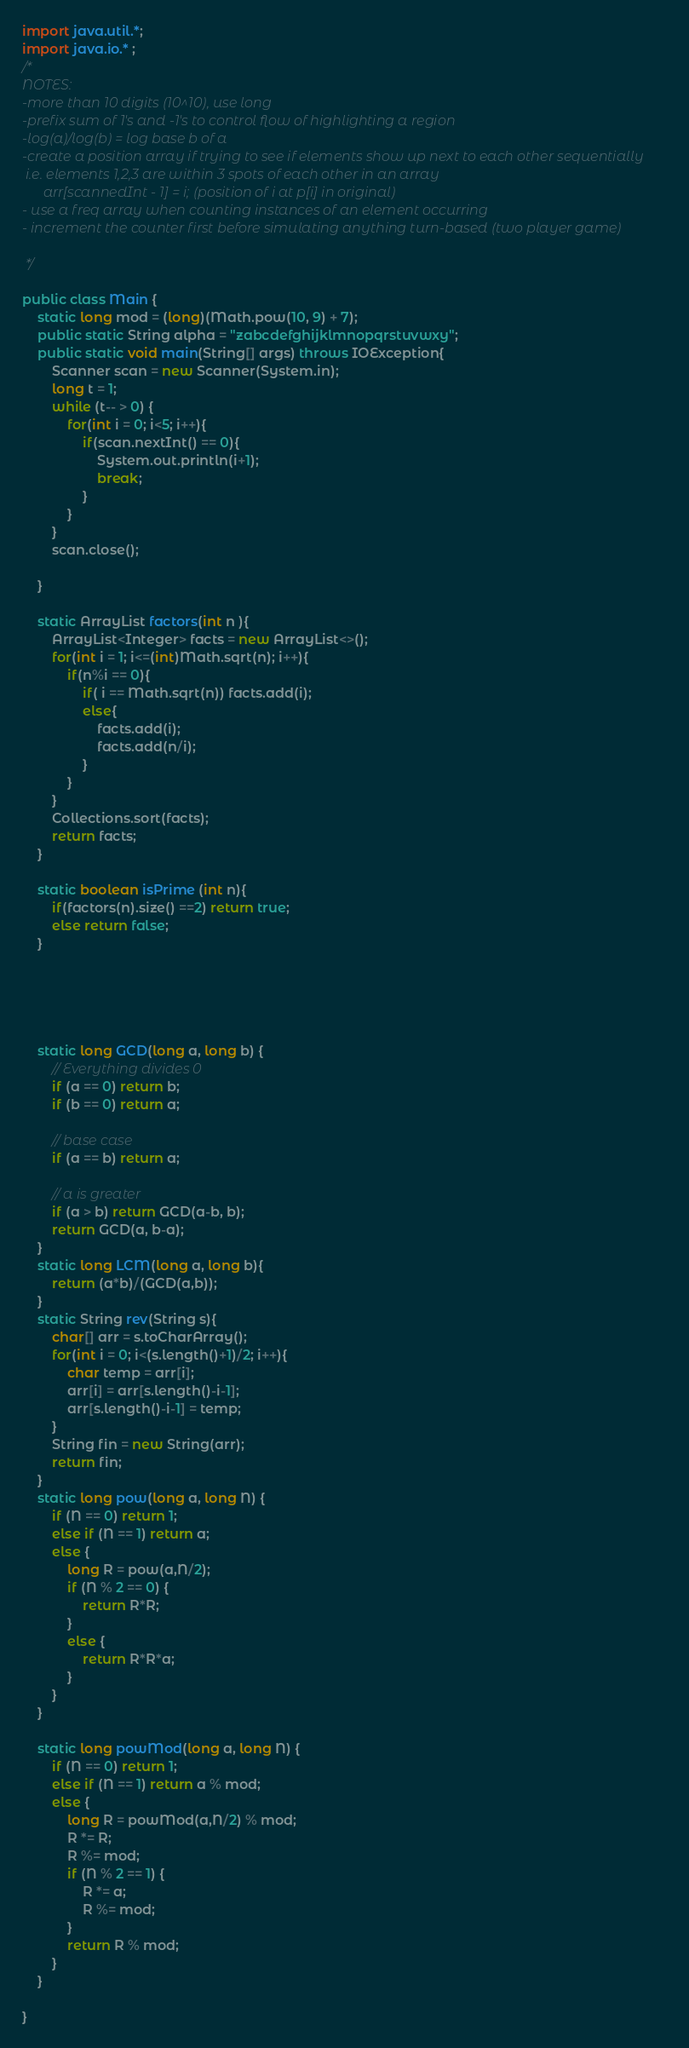Convert code to text. <code><loc_0><loc_0><loc_500><loc_500><_Java_>import java.util.*;
import java.io.* ;
/*
NOTES:
-more than 10 digits (10^10), use long
-prefix sum of 1's and -1's to control flow of highlighting a region
-log(a)/log(b) = log base b of a
-create a position array if trying to see if elements show up next to each other sequentially
 i.e. elements 1,2,3 are within 3 spots of each other in an array
      arr[scannedInt - 1] = i; (position of i at p[i] in original)
- use a freq array when counting instances of an element occurring
- increment the counter first before simulating anything turn-based (two player game)

 */

public class Main {
    static long mod = (long)(Math.pow(10, 9) + 7);
    public static String alpha = "zabcdefghijklmnopqrstuvwxy";
    public static void main(String[] args) throws IOException{
        Scanner scan = new Scanner(System.in);
        long t = 1;
        while (t-- > 0) {
            for(int i = 0; i<5; i++){
                if(scan.nextInt() == 0){
                    System.out.println(i+1);
                    break;
                }
            }
        }
        scan.close();

    }

    static ArrayList factors(int n ){
        ArrayList<Integer> facts = new ArrayList<>();
        for(int i = 1; i<=(int)Math.sqrt(n); i++){
            if(n%i == 0){
                if( i == Math.sqrt(n)) facts.add(i);
                else{
                    facts.add(i);
                    facts.add(n/i);
                }
            }
        }
        Collections.sort(facts);
        return facts;
    }

    static boolean isPrime (int n){
        if(factors(n).size() ==2) return true;
        else return false;
    }





    static long GCD(long a, long b) {
        // Everything divides 0
        if (a == 0) return b;
        if (b == 0) return a;

        // base case
        if (a == b) return a;

        // a is greater
        if (a > b) return GCD(a-b, b);
        return GCD(a, b-a);
    }
    static long LCM(long a, long b){
        return (a*b)/(GCD(a,b));
    }
    static String rev(String s){
        char[] arr = s.toCharArray();
        for(int i = 0; i<(s.length()+1)/2; i++){
            char temp = arr[i];
            arr[i] = arr[s.length()-i-1];
            arr[s.length()-i-1] = temp;
        }
        String fin = new String(arr);
        return fin;
    }
    static long pow(long a, long N) {
        if (N == 0) return 1;
        else if (N == 1) return a;
        else {
            long R = pow(a,N/2);
            if (N % 2 == 0) {
                return R*R;
            }
            else {
                return R*R*a;
            }
        }
    }

    static long powMod(long a, long N) {
        if (N == 0) return 1;
        else if (N == 1) return a % mod;
        else {
            long R = powMod(a,N/2) % mod;
            R *= R;
            R %= mod;
            if (N % 2 == 1) {
                R *= a;
                R %= mod;
            }
            return R % mod;
        }
    }

}</code> 